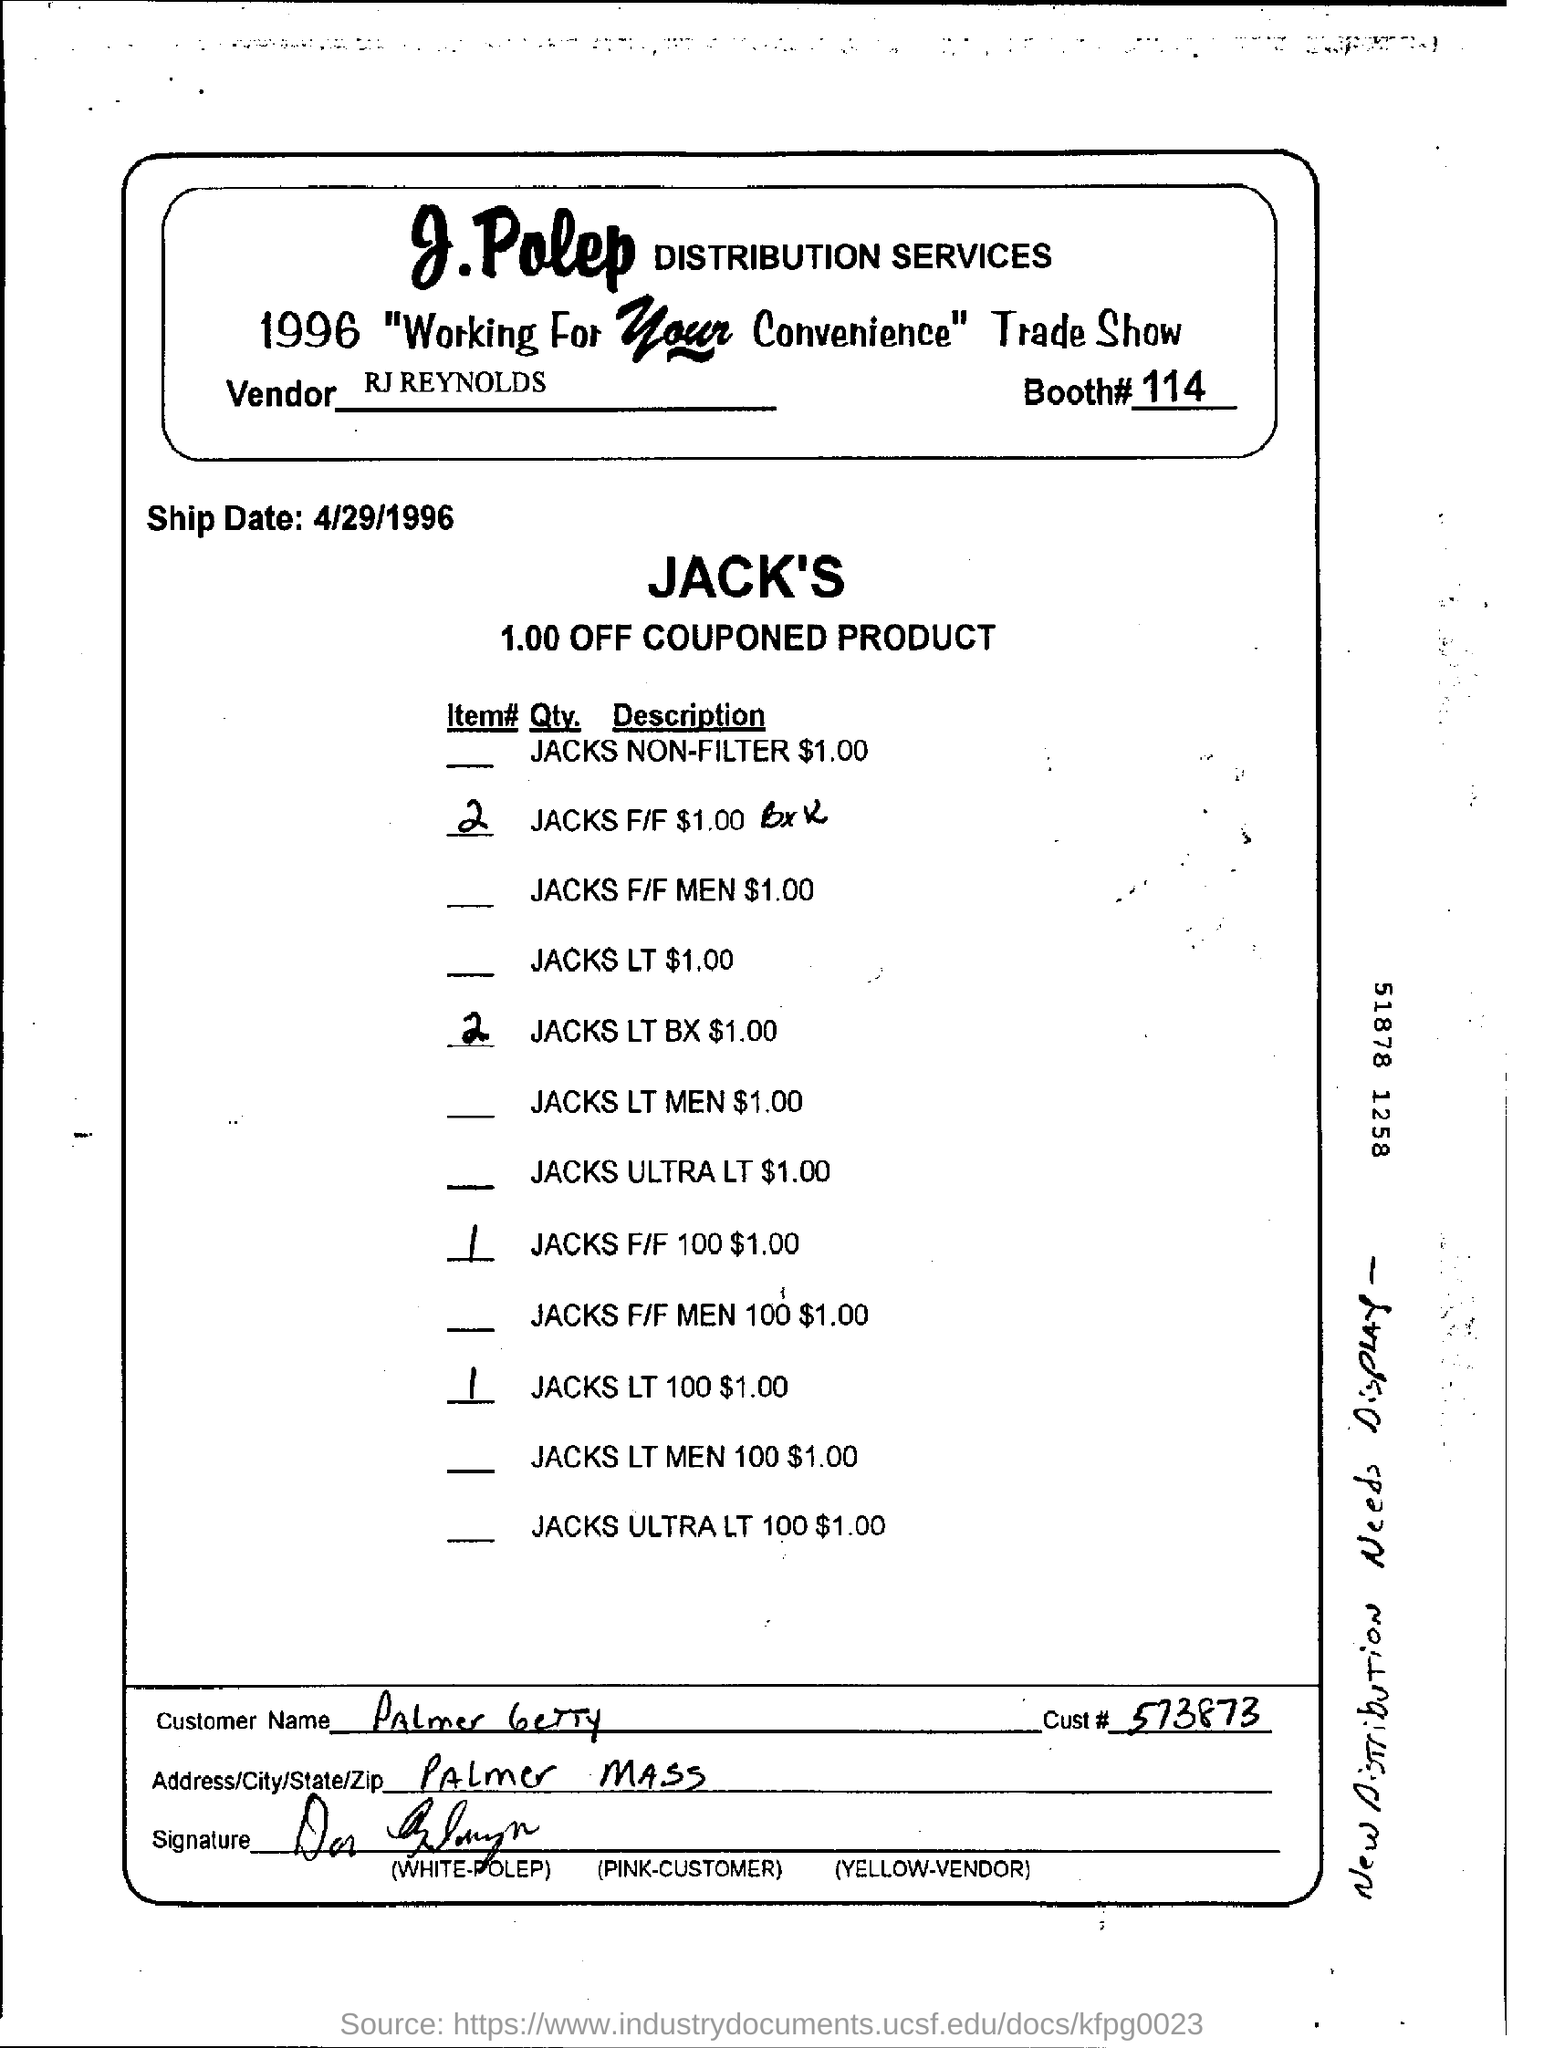Give some essential details in this illustration. The distribution services provided by J. Polep have been named. The ship date for April 29, 1996, has been determined. 